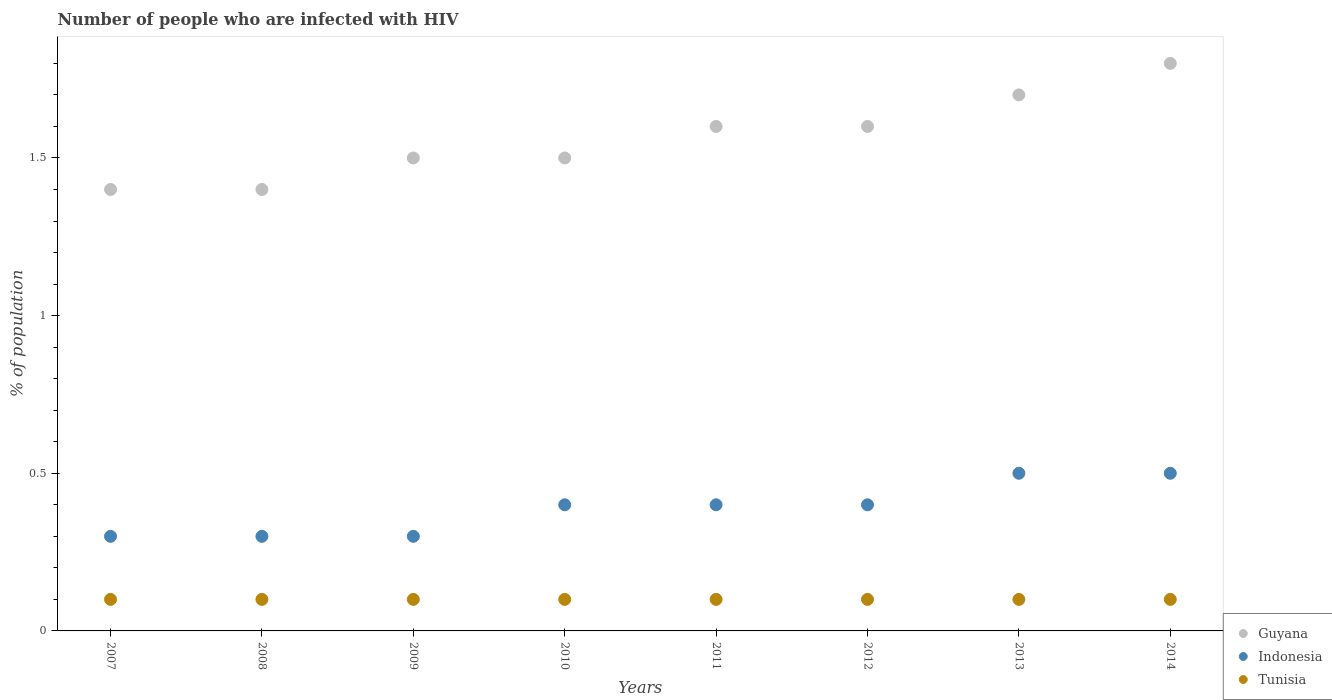What is the percentage of HIV infected population in in Indonesia in 2013?
Keep it short and to the point. 0.5. Across all years, what is the maximum percentage of HIV infected population in in Tunisia?
Your answer should be very brief. 0.1. In which year was the percentage of HIV infected population in in Guyana maximum?
Make the answer very short. 2014. In which year was the percentage of HIV infected population in in Indonesia minimum?
Provide a short and direct response. 2007. What is the total percentage of HIV infected population in in Indonesia in the graph?
Offer a very short reply. 3.1. What is the difference between the percentage of HIV infected population in in Indonesia in 2011 and that in 2014?
Offer a very short reply. -0.1. What is the difference between the percentage of HIV infected population in in Tunisia in 2011 and the percentage of HIV infected population in in Indonesia in 2012?
Your response must be concise. -0.3. What is the average percentage of HIV infected population in in Indonesia per year?
Provide a short and direct response. 0.39. In the year 2009, what is the difference between the percentage of HIV infected population in in Guyana and percentage of HIV infected population in in Tunisia?
Provide a succinct answer. 1.4. In how many years, is the percentage of HIV infected population in in Tunisia greater than 1 %?
Give a very brief answer. 0. What is the ratio of the percentage of HIV infected population in in Indonesia in 2009 to that in 2011?
Give a very brief answer. 0.75. Is the difference between the percentage of HIV infected population in in Guyana in 2011 and 2013 greater than the difference between the percentage of HIV infected population in in Tunisia in 2011 and 2013?
Provide a succinct answer. No. In how many years, is the percentage of HIV infected population in in Tunisia greater than the average percentage of HIV infected population in in Tunisia taken over all years?
Ensure brevity in your answer.  0. Is the sum of the percentage of HIV infected population in in Indonesia in 2010 and 2011 greater than the maximum percentage of HIV infected population in in Tunisia across all years?
Your answer should be compact. Yes. Is the percentage of HIV infected population in in Indonesia strictly less than the percentage of HIV infected population in in Tunisia over the years?
Offer a very short reply. No. What is the difference between two consecutive major ticks on the Y-axis?
Give a very brief answer. 0.5. Are the values on the major ticks of Y-axis written in scientific E-notation?
Your answer should be compact. No. Does the graph contain any zero values?
Give a very brief answer. No. What is the title of the graph?
Keep it short and to the point. Number of people who are infected with HIV. Does "Norway" appear as one of the legend labels in the graph?
Offer a terse response. No. What is the label or title of the X-axis?
Offer a very short reply. Years. What is the label or title of the Y-axis?
Give a very brief answer. % of population. What is the % of population of Guyana in 2007?
Your answer should be very brief. 1.4. What is the % of population of Tunisia in 2007?
Give a very brief answer. 0.1. What is the % of population in Guyana in 2008?
Make the answer very short. 1.4. What is the % of population in Guyana in 2009?
Provide a succinct answer. 1.5. What is the % of population in Tunisia in 2009?
Keep it short and to the point. 0.1. What is the % of population of Tunisia in 2010?
Provide a short and direct response. 0.1. What is the % of population in Tunisia in 2011?
Offer a very short reply. 0.1. What is the % of population in Guyana in 2013?
Ensure brevity in your answer.  1.7. What is the % of population of Tunisia in 2013?
Keep it short and to the point. 0.1. Across all years, what is the maximum % of population of Guyana?
Provide a short and direct response. 1.8. Across all years, what is the minimum % of population of Guyana?
Provide a succinct answer. 1.4. What is the total % of population of Tunisia in the graph?
Your answer should be compact. 0.8. What is the difference between the % of population in Guyana in 2007 and that in 2009?
Make the answer very short. -0.1. What is the difference between the % of population in Indonesia in 2007 and that in 2009?
Ensure brevity in your answer.  0. What is the difference between the % of population of Tunisia in 2007 and that in 2009?
Provide a short and direct response. 0. What is the difference between the % of population of Indonesia in 2007 and that in 2010?
Give a very brief answer. -0.1. What is the difference between the % of population in Guyana in 2007 and that in 2012?
Your answer should be very brief. -0.2. What is the difference between the % of population of Indonesia in 2007 and that in 2012?
Ensure brevity in your answer.  -0.1. What is the difference between the % of population in Guyana in 2007 and that in 2013?
Provide a succinct answer. -0.3. What is the difference between the % of population of Indonesia in 2007 and that in 2014?
Make the answer very short. -0.2. What is the difference between the % of population in Tunisia in 2007 and that in 2014?
Offer a terse response. 0. What is the difference between the % of population in Guyana in 2008 and that in 2009?
Give a very brief answer. -0.1. What is the difference between the % of population of Indonesia in 2008 and that in 2009?
Provide a succinct answer. 0. What is the difference between the % of population of Tunisia in 2008 and that in 2009?
Provide a succinct answer. 0. What is the difference between the % of population of Guyana in 2008 and that in 2010?
Your answer should be compact. -0.1. What is the difference between the % of population in Indonesia in 2008 and that in 2011?
Your answer should be compact. -0.1. What is the difference between the % of population in Guyana in 2008 and that in 2012?
Ensure brevity in your answer.  -0.2. What is the difference between the % of population of Indonesia in 2008 and that in 2012?
Give a very brief answer. -0.1. What is the difference between the % of population in Tunisia in 2008 and that in 2012?
Keep it short and to the point. 0. What is the difference between the % of population of Guyana in 2008 and that in 2013?
Offer a terse response. -0.3. What is the difference between the % of population in Indonesia in 2008 and that in 2014?
Make the answer very short. -0.2. What is the difference between the % of population of Tunisia in 2008 and that in 2014?
Offer a very short reply. 0. What is the difference between the % of population of Indonesia in 2009 and that in 2010?
Your response must be concise. -0.1. What is the difference between the % of population in Indonesia in 2009 and that in 2011?
Make the answer very short. -0.1. What is the difference between the % of population of Indonesia in 2009 and that in 2013?
Your answer should be compact. -0.2. What is the difference between the % of population in Tunisia in 2009 and that in 2013?
Offer a very short reply. 0. What is the difference between the % of population in Indonesia in 2009 and that in 2014?
Ensure brevity in your answer.  -0.2. What is the difference between the % of population of Tunisia in 2009 and that in 2014?
Your answer should be very brief. 0. What is the difference between the % of population in Indonesia in 2010 and that in 2011?
Give a very brief answer. 0. What is the difference between the % of population of Tunisia in 2010 and that in 2012?
Keep it short and to the point. 0. What is the difference between the % of population of Indonesia in 2010 and that in 2013?
Make the answer very short. -0.1. What is the difference between the % of population of Tunisia in 2010 and that in 2014?
Provide a short and direct response. 0. What is the difference between the % of population of Guyana in 2011 and that in 2012?
Make the answer very short. 0. What is the difference between the % of population in Indonesia in 2011 and that in 2012?
Make the answer very short. 0. What is the difference between the % of population of Indonesia in 2011 and that in 2013?
Ensure brevity in your answer.  -0.1. What is the difference between the % of population of Tunisia in 2011 and that in 2013?
Offer a terse response. 0. What is the difference between the % of population in Tunisia in 2011 and that in 2014?
Ensure brevity in your answer.  0. What is the difference between the % of population in Guyana in 2012 and that in 2013?
Offer a very short reply. -0.1. What is the difference between the % of population of Indonesia in 2012 and that in 2013?
Give a very brief answer. -0.1. What is the difference between the % of population in Guyana in 2012 and that in 2014?
Provide a succinct answer. -0.2. What is the difference between the % of population in Tunisia in 2012 and that in 2014?
Give a very brief answer. 0. What is the difference between the % of population of Guyana in 2013 and that in 2014?
Your response must be concise. -0.1. What is the difference between the % of population in Indonesia in 2013 and that in 2014?
Keep it short and to the point. 0. What is the difference between the % of population in Tunisia in 2013 and that in 2014?
Offer a very short reply. 0. What is the difference between the % of population in Guyana in 2007 and the % of population in Indonesia in 2008?
Your response must be concise. 1.1. What is the difference between the % of population in Guyana in 2007 and the % of population in Tunisia in 2008?
Ensure brevity in your answer.  1.3. What is the difference between the % of population in Guyana in 2007 and the % of population in Indonesia in 2009?
Your answer should be compact. 1.1. What is the difference between the % of population in Guyana in 2007 and the % of population in Tunisia in 2009?
Keep it short and to the point. 1.3. What is the difference between the % of population in Guyana in 2007 and the % of population in Indonesia in 2010?
Keep it short and to the point. 1. What is the difference between the % of population of Guyana in 2007 and the % of population of Tunisia in 2011?
Provide a succinct answer. 1.3. What is the difference between the % of population of Indonesia in 2007 and the % of population of Tunisia in 2011?
Your response must be concise. 0.2. What is the difference between the % of population of Guyana in 2007 and the % of population of Tunisia in 2012?
Give a very brief answer. 1.3. What is the difference between the % of population in Indonesia in 2007 and the % of population in Tunisia in 2012?
Offer a very short reply. 0.2. What is the difference between the % of population of Guyana in 2007 and the % of population of Tunisia in 2013?
Offer a very short reply. 1.3. What is the difference between the % of population of Guyana in 2007 and the % of population of Indonesia in 2014?
Provide a short and direct response. 0.9. What is the difference between the % of population in Guyana in 2007 and the % of population in Tunisia in 2014?
Your answer should be very brief. 1.3. What is the difference between the % of population of Guyana in 2008 and the % of population of Tunisia in 2009?
Provide a short and direct response. 1.3. What is the difference between the % of population in Guyana in 2008 and the % of population in Tunisia in 2010?
Keep it short and to the point. 1.3. What is the difference between the % of population in Indonesia in 2008 and the % of population in Tunisia in 2011?
Provide a succinct answer. 0.2. What is the difference between the % of population of Guyana in 2008 and the % of population of Indonesia in 2012?
Provide a succinct answer. 1. What is the difference between the % of population of Guyana in 2008 and the % of population of Indonesia in 2013?
Ensure brevity in your answer.  0.9. What is the difference between the % of population in Indonesia in 2008 and the % of population in Tunisia in 2013?
Keep it short and to the point. 0.2. What is the difference between the % of population in Guyana in 2008 and the % of population in Indonesia in 2014?
Your answer should be very brief. 0.9. What is the difference between the % of population in Guyana in 2008 and the % of population in Tunisia in 2014?
Provide a short and direct response. 1.3. What is the difference between the % of population in Guyana in 2009 and the % of population in Tunisia in 2010?
Keep it short and to the point. 1.4. What is the difference between the % of population in Indonesia in 2009 and the % of population in Tunisia in 2010?
Keep it short and to the point. 0.2. What is the difference between the % of population of Guyana in 2009 and the % of population of Indonesia in 2011?
Keep it short and to the point. 1.1. What is the difference between the % of population in Indonesia in 2009 and the % of population in Tunisia in 2011?
Provide a succinct answer. 0.2. What is the difference between the % of population in Guyana in 2009 and the % of population in Tunisia in 2012?
Make the answer very short. 1.4. What is the difference between the % of population of Indonesia in 2009 and the % of population of Tunisia in 2012?
Keep it short and to the point. 0.2. What is the difference between the % of population in Guyana in 2009 and the % of population in Indonesia in 2013?
Keep it short and to the point. 1. What is the difference between the % of population in Guyana in 2009 and the % of population in Tunisia in 2013?
Your response must be concise. 1.4. What is the difference between the % of population of Indonesia in 2009 and the % of population of Tunisia in 2013?
Provide a short and direct response. 0.2. What is the difference between the % of population of Guyana in 2009 and the % of population of Tunisia in 2014?
Offer a very short reply. 1.4. What is the difference between the % of population of Indonesia in 2010 and the % of population of Tunisia in 2011?
Your response must be concise. 0.3. What is the difference between the % of population of Guyana in 2010 and the % of population of Tunisia in 2012?
Give a very brief answer. 1.4. What is the difference between the % of population of Guyana in 2010 and the % of population of Indonesia in 2013?
Offer a terse response. 1. What is the difference between the % of population in Guyana in 2010 and the % of population in Tunisia in 2013?
Your response must be concise. 1.4. What is the difference between the % of population in Indonesia in 2010 and the % of population in Tunisia in 2013?
Provide a short and direct response. 0.3. What is the difference between the % of population in Guyana in 2010 and the % of population in Tunisia in 2014?
Keep it short and to the point. 1.4. What is the difference between the % of population of Indonesia in 2010 and the % of population of Tunisia in 2014?
Provide a succinct answer. 0.3. What is the difference between the % of population of Guyana in 2011 and the % of population of Indonesia in 2012?
Your answer should be very brief. 1.2. What is the difference between the % of population of Guyana in 2011 and the % of population of Tunisia in 2012?
Your answer should be very brief. 1.5. What is the difference between the % of population in Indonesia in 2011 and the % of population in Tunisia in 2012?
Your response must be concise. 0.3. What is the difference between the % of population in Guyana in 2011 and the % of population in Indonesia in 2013?
Provide a succinct answer. 1.1. What is the difference between the % of population of Indonesia in 2011 and the % of population of Tunisia in 2013?
Offer a very short reply. 0.3. What is the difference between the % of population in Guyana in 2011 and the % of population in Tunisia in 2014?
Ensure brevity in your answer.  1.5. What is the difference between the % of population of Guyana in 2012 and the % of population of Indonesia in 2013?
Make the answer very short. 1.1. What is the difference between the % of population of Guyana in 2012 and the % of population of Indonesia in 2014?
Provide a short and direct response. 1.1. What is the difference between the % of population of Indonesia in 2012 and the % of population of Tunisia in 2014?
Keep it short and to the point. 0.3. What is the difference between the % of population in Guyana in 2013 and the % of population in Tunisia in 2014?
Keep it short and to the point. 1.6. What is the difference between the % of population of Indonesia in 2013 and the % of population of Tunisia in 2014?
Offer a very short reply. 0.4. What is the average % of population of Guyana per year?
Your answer should be compact. 1.56. What is the average % of population of Indonesia per year?
Provide a short and direct response. 0.39. What is the average % of population in Tunisia per year?
Your answer should be very brief. 0.1. In the year 2007, what is the difference between the % of population of Guyana and % of population of Indonesia?
Your response must be concise. 1.1. In the year 2007, what is the difference between the % of population of Indonesia and % of population of Tunisia?
Make the answer very short. 0.2. In the year 2008, what is the difference between the % of population in Guyana and % of population in Indonesia?
Your answer should be very brief. 1.1. In the year 2009, what is the difference between the % of population in Guyana and % of population in Indonesia?
Provide a short and direct response. 1.2. In the year 2009, what is the difference between the % of population in Guyana and % of population in Tunisia?
Ensure brevity in your answer.  1.4. In the year 2010, what is the difference between the % of population of Guyana and % of population of Tunisia?
Ensure brevity in your answer.  1.4. In the year 2011, what is the difference between the % of population of Guyana and % of population of Indonesia?
Keep it short and to the point. 1.2. In the year 2011, what is the difference between the % of population in Indonesia and % of population in Tunisia?
Offer a very short reply. 0.3. In the year 2012, what is the difference between the % of population of Indonesia and % of population of Tunisia?
Your answer should be compact. 0.3. In the year 2013, what is the difference between the % of population in Guyana and % of population in Tunisia?
Ensure brevity in your answer.  1.6. In the year 2014, what is the difference between the % of population in Guyana and % of population in Indonesia?
Your response must be concise. 1.3. In the year 2014, what is the difference between the % of population of Indonesia and % of population of Tunisia?
Provide a short and direct response. 0.4. What is the ratio of the % of population of Guyana in 2007 to that in 2008?
Your answer should be very brief. 1. What is the ratio of the % of population of Indonesia in 2007 to that in 2010?
Keep it short and to the point. 0.75. What is the ratio of the % of population in Guyana in 2007 to that in 2011?
Keep it short and to the point. 0.88. What is the ratio of the % of population of Indonesia in 2007 to that in 2011?
Your response must be concise. 0.75. What is the ratio of the % of population of Tunisia in 2007 to that in 2012?
Your answer should be very brief. 1. What is the ratio of the % of population of Guyana in 2007 to that in 2013?
Ensure brevity in your answer.  0.82. What is the ratio of the % of population of Tunisia in 2007 to that in 2013?
Make the answer very short. 1. What is the ratio of the % of population of Guyana in 2007 to that in 2014?
Your answer should be very brief. 0.78. What is the ratio of the % of population in Indonesia in 2007 to that in 2014?
Provide a succinct answer. 0.6. What is the ratio of the % of population in Tunisia in 2007 to that in 2014?
Make the answer very short. 1. What is the ratio of the % of population in Tunisia in 2008 to that in 2009?
Your answer should be very brief. 1. What is the ratio of the % of population of Guyana in 2008 to that in 2011?
Give a very brief answer. 0.88. What is the ratio of the % of population in Indonesia in 2008 to that in 2011?
Offer a terse response. 0.75. What is the ratio of the % of population of Guyana in 2008 to that in 2013?
Provide a short and direct response. 0.82. What is the ratio of the % of population in Indonesia in 2008 to that in 2013?
Your answer should be very brief. 0.6. What is the ratio of the % of population in Tunisia in 2008 to that in 2013?
Keep it short and to the point. 1. What is the ratio of the % of population in Guyana in 2008 to that in 2014?
Offer a very short reply. 0.78. What is the ratio of the % of population of Tunisia in 2008 to that in 2014?
Make the answer very short. 1. What is the ratio of the % of population of Guyana in 2009 to that in 2010?
Ensure brevity in your answer.  1. What is the ratio of the % of population in Tunisia in 2009 to that in 2010?
Provide a short and direct response. 1. What is the ratio of the % of population in Guyana in 2009 to that in 2013?
Offer a very short reply. 0.88. What is the ratio of the % of population in Guyana in 2009 to that in 2014?
Your answer should be very brief. 0.83. What is the ratio of the % of population in Guyana in 2010 to that in 2011?
Make the answer very short. 0.94. What is the ratio of the % of population of Tunisia in 2010 to that in 2011?
Make the answer very short. 1. What is the ratio of the % of population in Guyana in 2010 to that in 2012?
Offer a very short reply. 0.94. What is the ratio of the % of population of Indonesia in 2010 to that in 2012?
Ensure brevity in your answer.  1. What is the ratio of the % of population in Tunisia in 2010 to that in 2012?
Your answer should be very brief. 1. What is the ratio of the % of population of Guyana in 2010 to that in 2013?
Your answer should be compact. 0.88. What is the ratio of the % of population in Indonesia in 2010 to that in 2013?
Provide a succinct answer. 0.8. What is the ratio of the % of population of Tunisia in 2010 to that in 2013?
Provide a succinct answer. 1. What is the ratio of the % of population of Guyana in 2010 to that in 2014?
Give a very brief answer. 0.83. What is the ratio of the % of population in Tunisia in 2010 to that in 2014?
Keep it short and to the point. 1. What is the ratio of the % of population of Tunisia in 2011 to that in 2012?
Keep it short and to the point. 1. What is the ratio of the % of population in Tunisia in 2011 to that in 2014?
Your answer should be very brief. 1. What is the ratio of the % of population of Indonesia in 2012 to that in 2013?
Your response must be concise. 0.8. What is the ratio of the % of population in Tunisia in 2012 to that in 2014?
Your answer should be compact. 1. What is the ratio of the % of population in Guyana in 2013 to that in 2014?
Keep it short and to the point. 0.94. What is the ratio of the % of population in Indonesia in 2013 to that in 2014?
Give a very brief answer. 1. What is the difference between the highest and the second highest % of population in Indonesia?
Ensure brevity in your answer.  0. What is the difference between the highest and the second highest % of population of Tunisia?
Provide a short and direct response. 0. What is the difference between the highest and the lowest % of population in Guyana?
Your response must be concise. 0.4. 